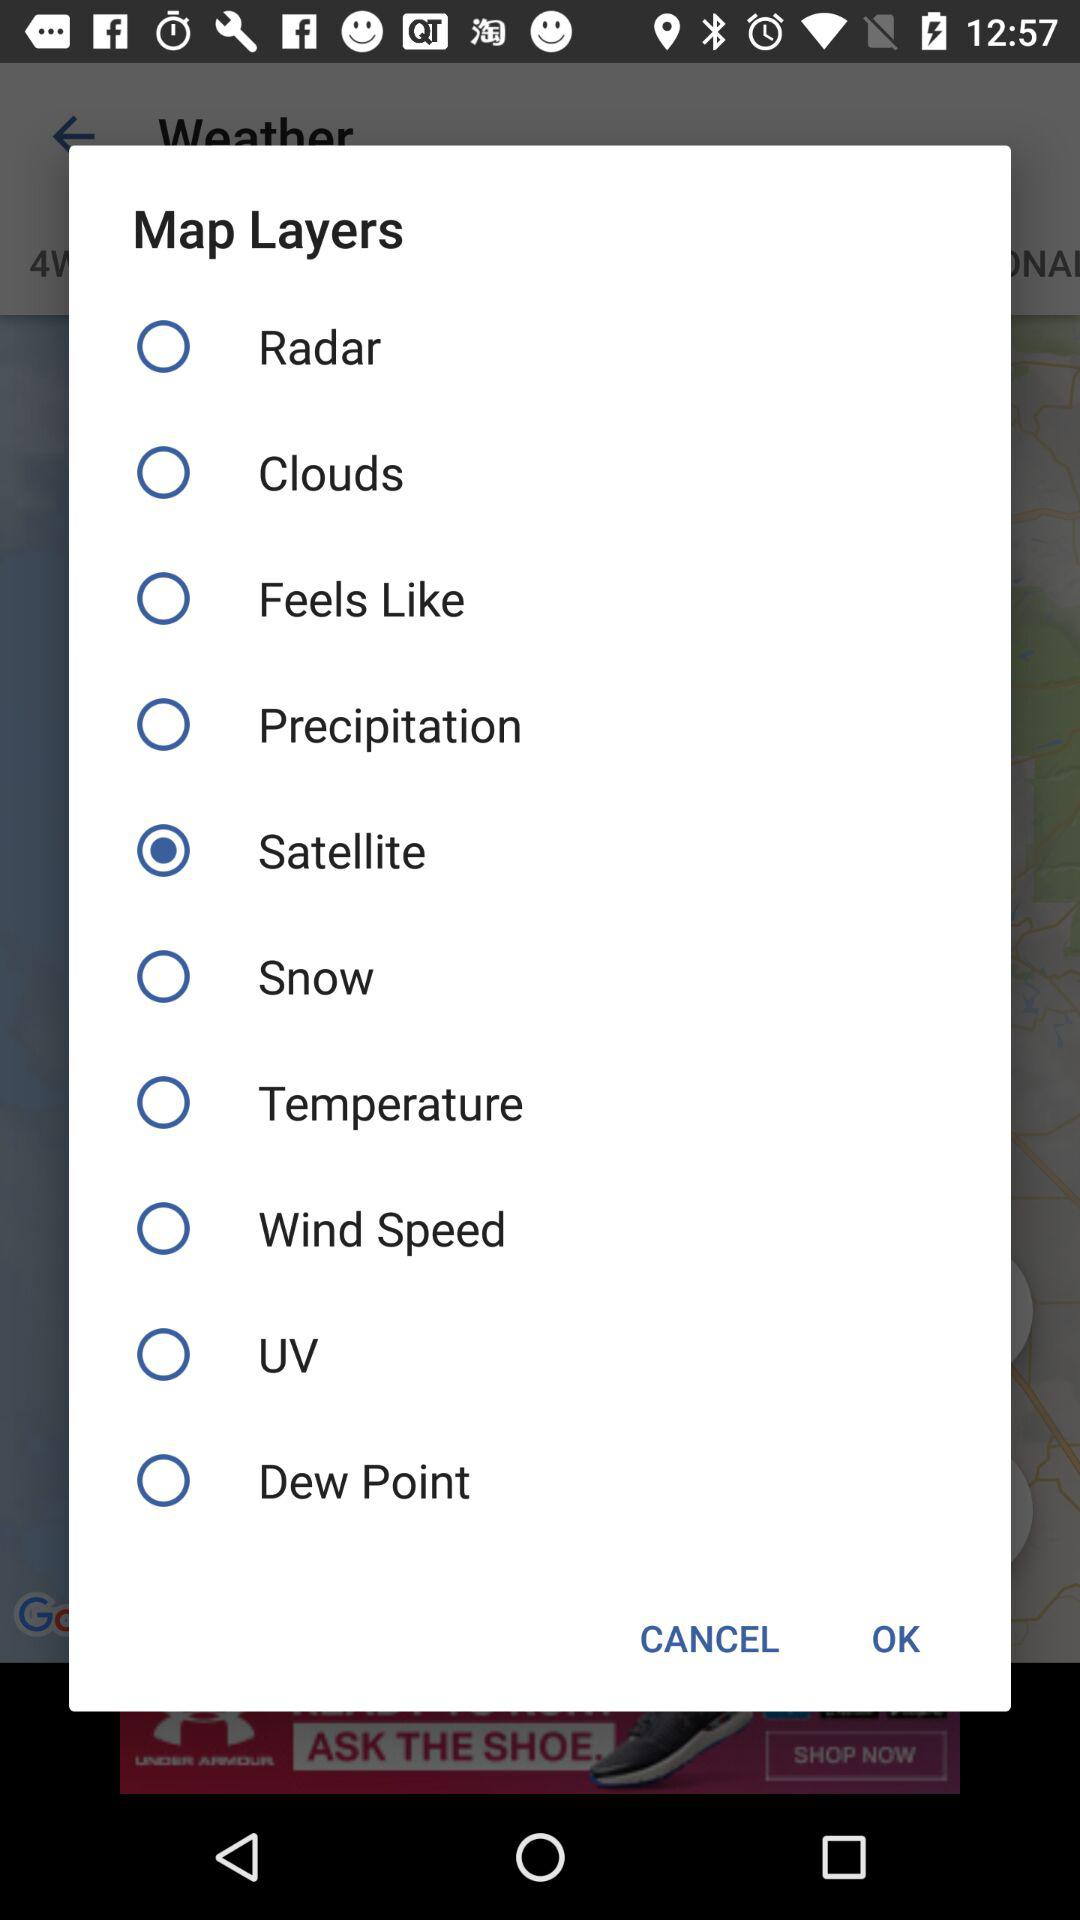Which is the selected map layer? The selected map layer is "Satellite". 